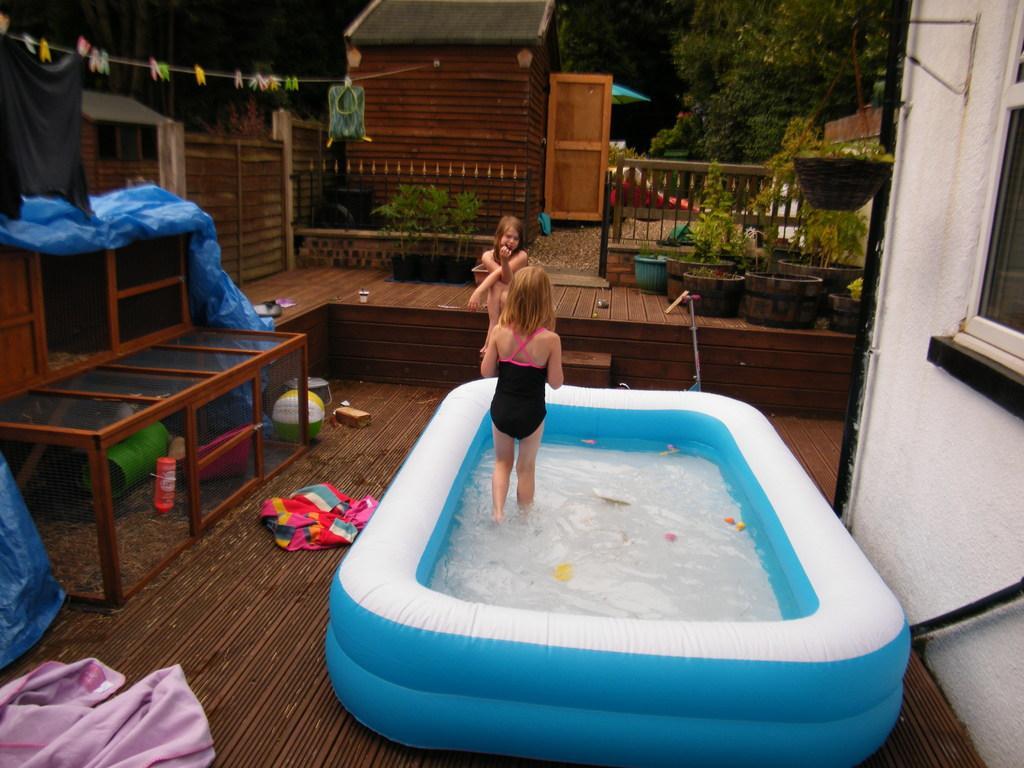Could you give a brief overview of what you see in this image? In the image we can see there is a bathtub. This tube contains of water and there are two girls. One girl is walking in this bath tub and other girl is sitting over here and it contains of floor and on floor there is cloth, wall, bottle and on the right side there is a building. This building contains one window and there are small plants in the pot and a red color house with orange color door and this wire is attached to this house and in the background there is tree. 